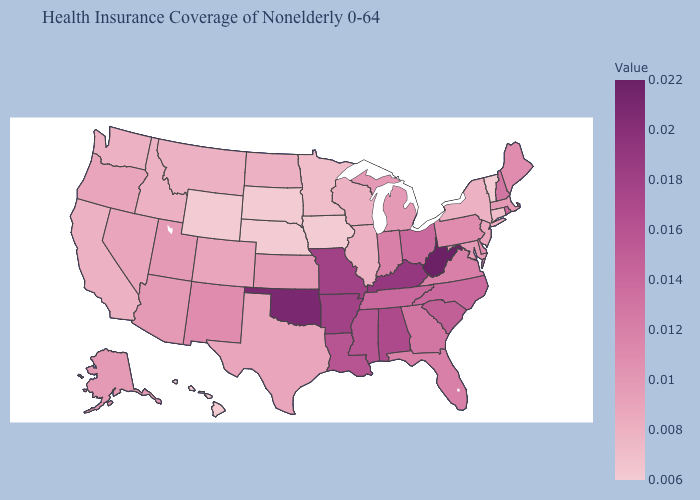Does Georgia have a lower value than Arkansas?
Write a very short answer. Yes. Does Oregon have a higher value than Louisiana?
Quick response, please. No. Does Mississippi have the highest value in the USA?
Write a very short answer. No. Does Texas have a higher value than Maine?
Quick response, please. No. Which states hav the highest value in the West?
Quick response, please. New Mexico. Which states have the lowest value in the West?
Concise answer only. Hawaii, Wyoming. 